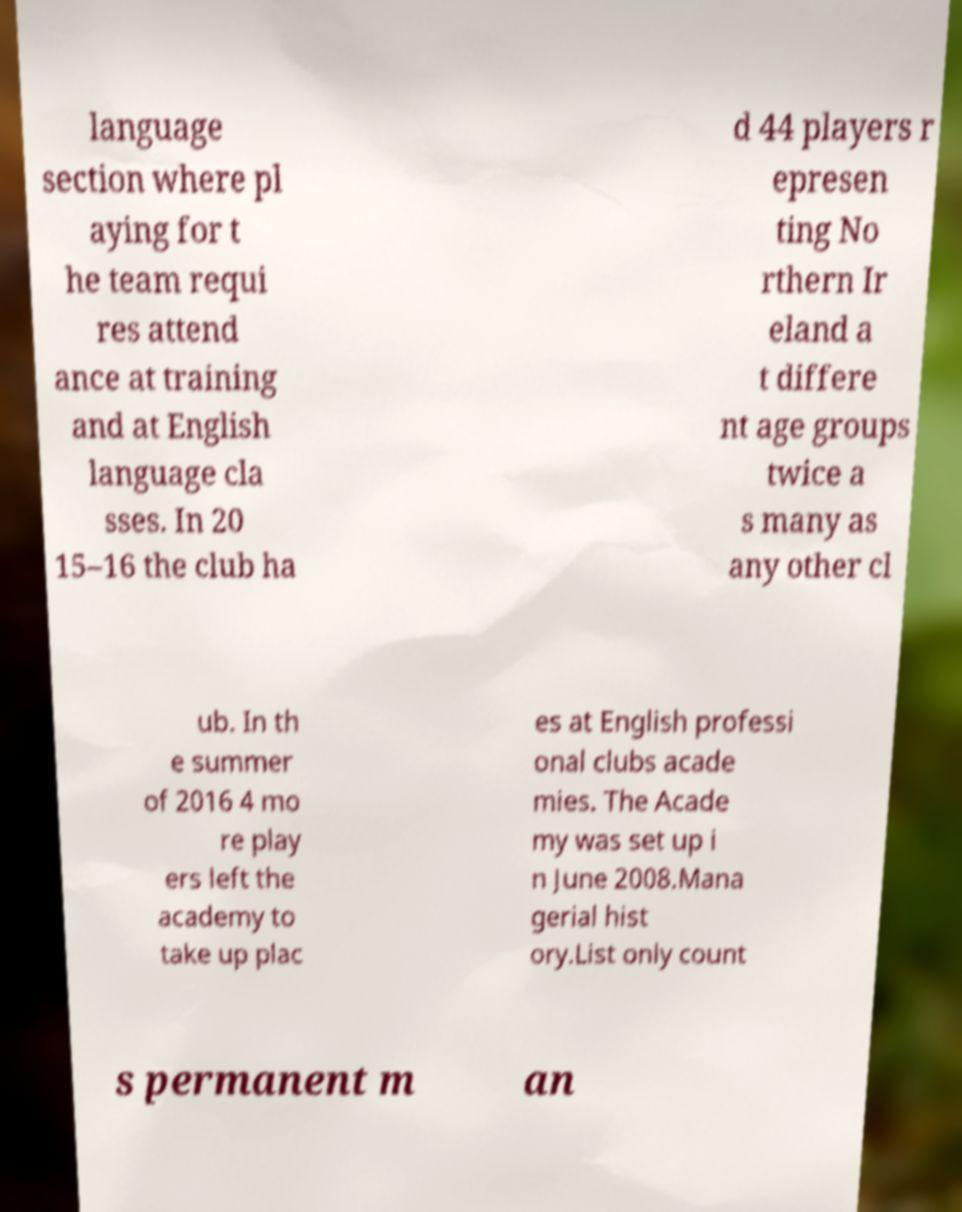Could you extract and type out the text from this image? language section where pl aying for t he team requi res attend ance at training and at English language cla sses. In 20 15–16 the club ha d 44 players r epresen ting No rthern Ir eland a t differe nt age groups twice a s many as any other cl ub. In th e summer of 2016 4 mo re play ers left the academy to take up plac es at English professi onal clubs acade mies. The Acade my was set up i n June 2008.Mana gerial hist ory.List only count s permanent m an 